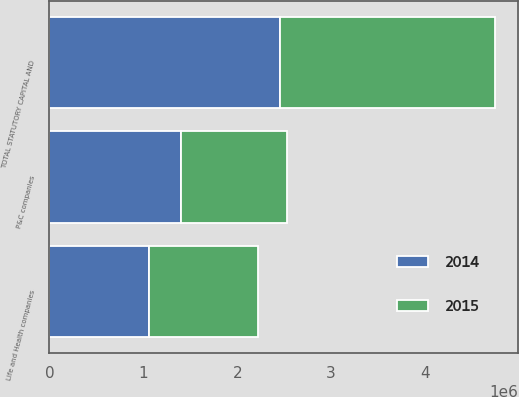<chart> <loc_0><loc_0><loc_500><loc_500><stacked_bar_chart><ecel><fcel>P&C companies<fcel>Life and Health companies<fcel>TOTAL STATUTORY CAPITAL AND<nl><fcel>2015<fcel>1.13798e+06<fcel>1.15314e+06<fcel>2.29112e+06<nl><fcel>2014<fcel>1.3963e+06<fcel>1.06417e+06<fcel>2.46048e+06<nl></chart> 